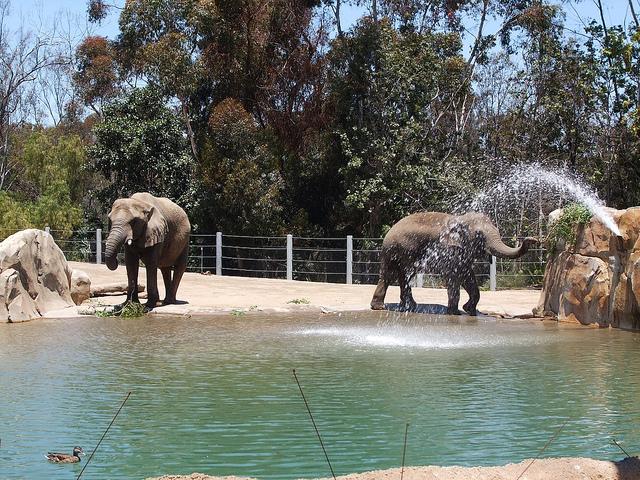What color is the water?
Quick response, please. Blue. Are these elephants in their natural habitat?
Give a very brief answer. No. What animals are these?
Concise answer only. Elephants. 